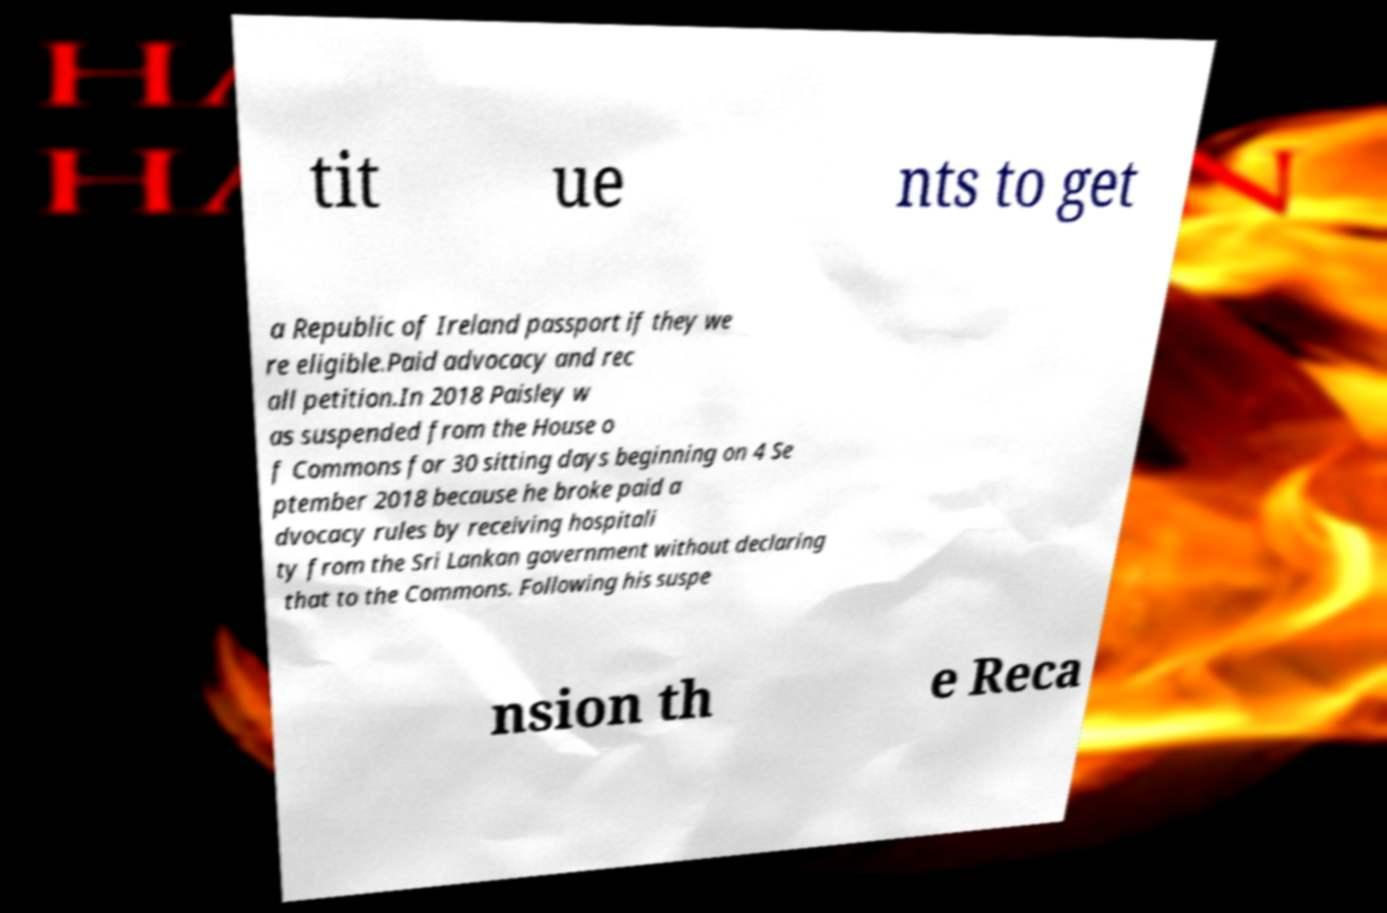For documentation purposes, I need the text within this image transcribed. Could you provide that? tit ue nts to get a Republic of Ireland passport if they we re eligible.Paid advocacy and rec all petition.In 2018 Paisley w as suspended from the House o f Commons for 30 sitting days beginning on 4 Se ptember 2018 because he broke paid a dvocacy rules by receiving hospitali ty from the Sri Lankan government without declaring that to the Commons. Following his suspe nsion th e Reca 